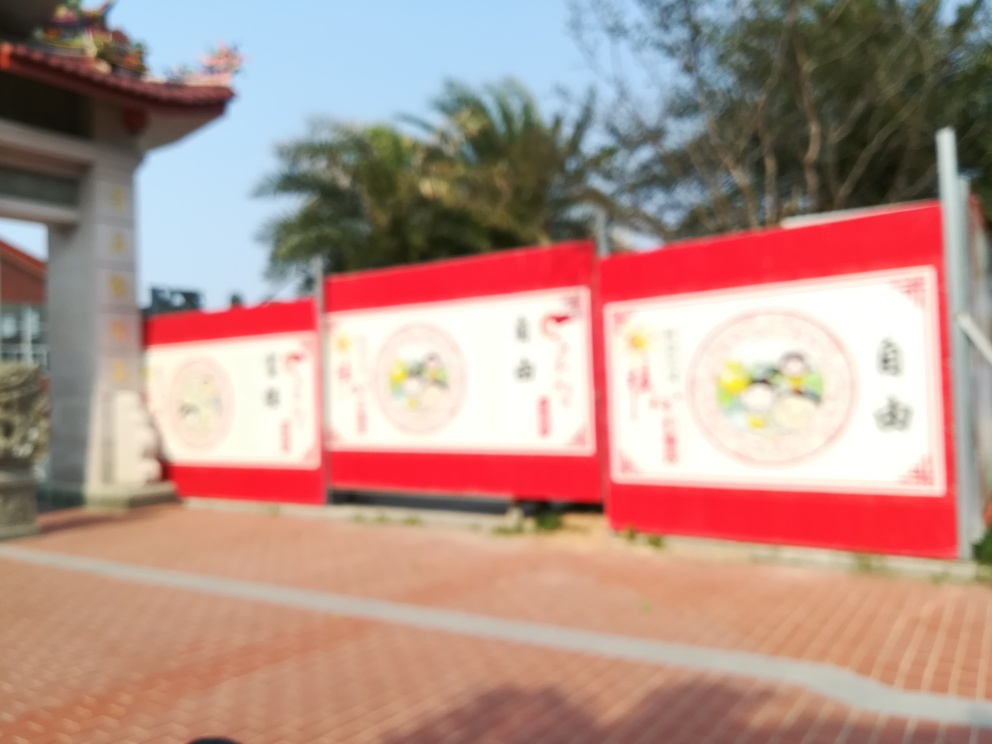What time of day does it look like in the photo? Given the lighting and shadows in the photo, it seems to be taken during daytime, probably in the late morning or early afternoon. 